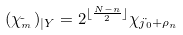<formula> <loc_0><loc_0><loc_500><loc_500>( \chi _ { \tilde { \L } _ { m } } ) _ { | Y } = 2 ^ { \lfloor \frac { N - n } { 2 } \rfloor } \chi _ { j \dot { \L } _ { 0 } + \rho _ { n } }</formula> 